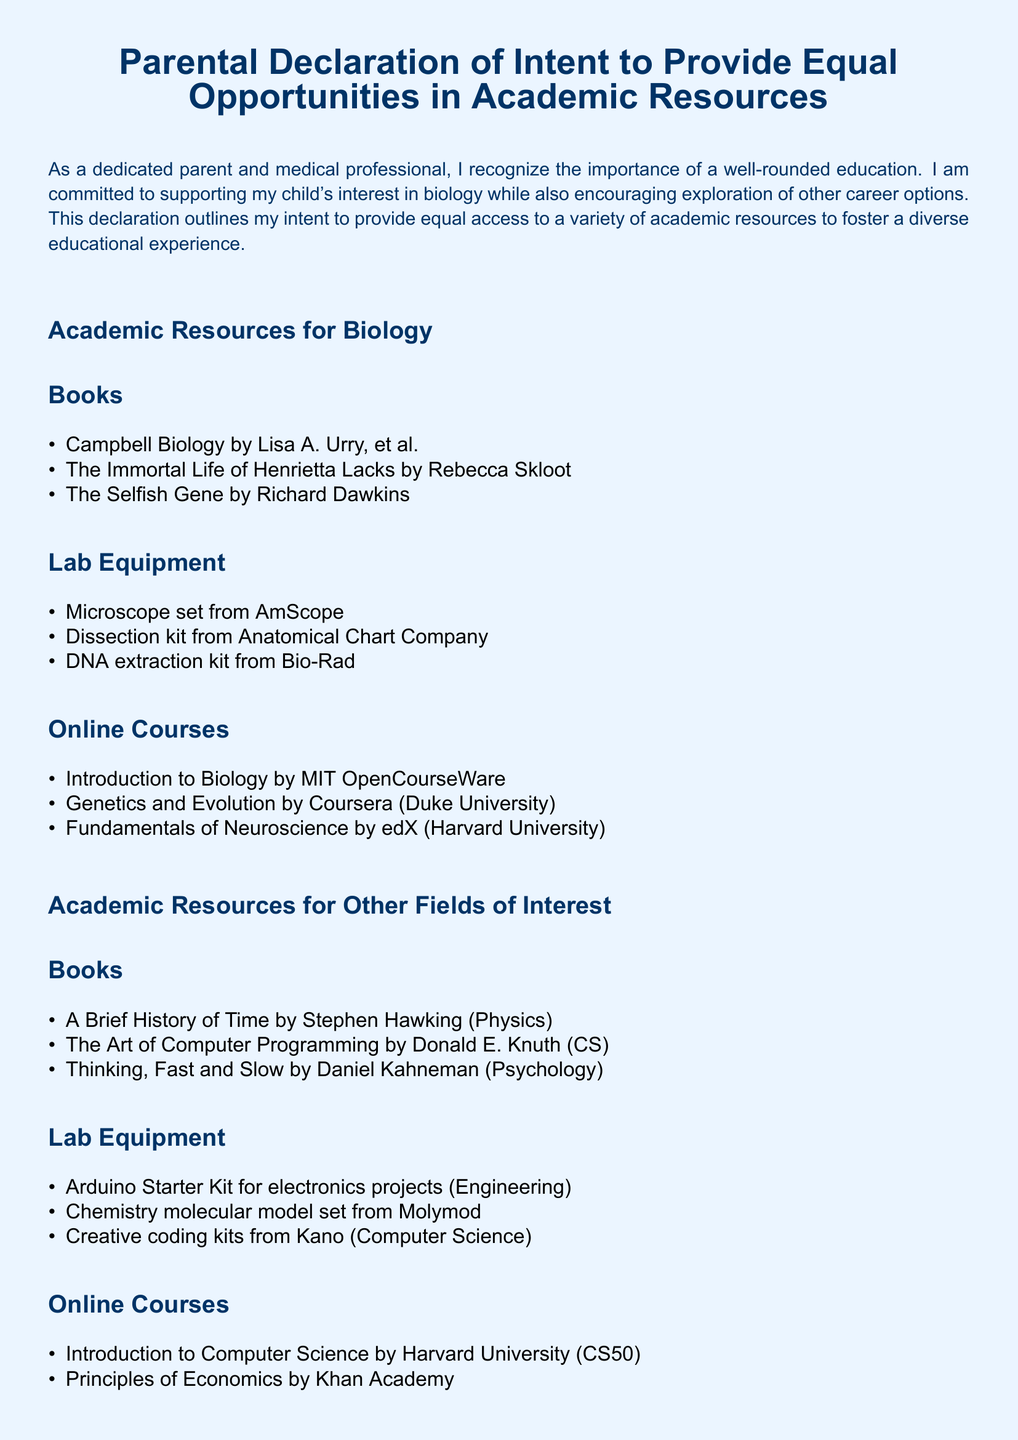What is the title of the document? The title is clearly stated at the beginning of the document.
Answer: Parental Declaration of Intent to Provide Equal Opportunities in Academic Resources Who is the author of this declaration? The declaration mentions the author as a dedicated parent and medical professional.
Answer: A dedicated parent and medical professional Name one biology book listed in the document. The document includes several biology books under the academic resources for biology section.
Answer: Campbell Biology by Lisa A. Urry, et al What type of lab equipment is mentioned for biology? The list provides specific types of lab equipment under the biology category.
Answer: Microscope set from AmScope Which online course is provided for computer science? The document includes a specific online course related to computer science under other fields of interest.
Answer: Introduction to Computer Science by Harvard University (CS50) How many sections are there in this document? The document is organized into distinct sections, which can be counted.
Answer: 2 What is the purpose of this declaration? The purpose is clearly stated within the introductory paragraph of the document.
Answer: To provide equal access to a variety of academic resources Who can sign this declaration? The document is tailored for a specific type of author, as indicated at the end.
Answer: A parent 